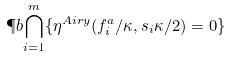Convert formula to latex. <formula><loc_0><loc_0><loc_500><loc_500>\P b { \bigcap _ { i = 1 } ^ { m } \{ \eta ^ { A i r y } ( f _ { i } ^ { a } / \kappa , s _ { i } \kappa / 2 ) = 0 \} }</formula> 